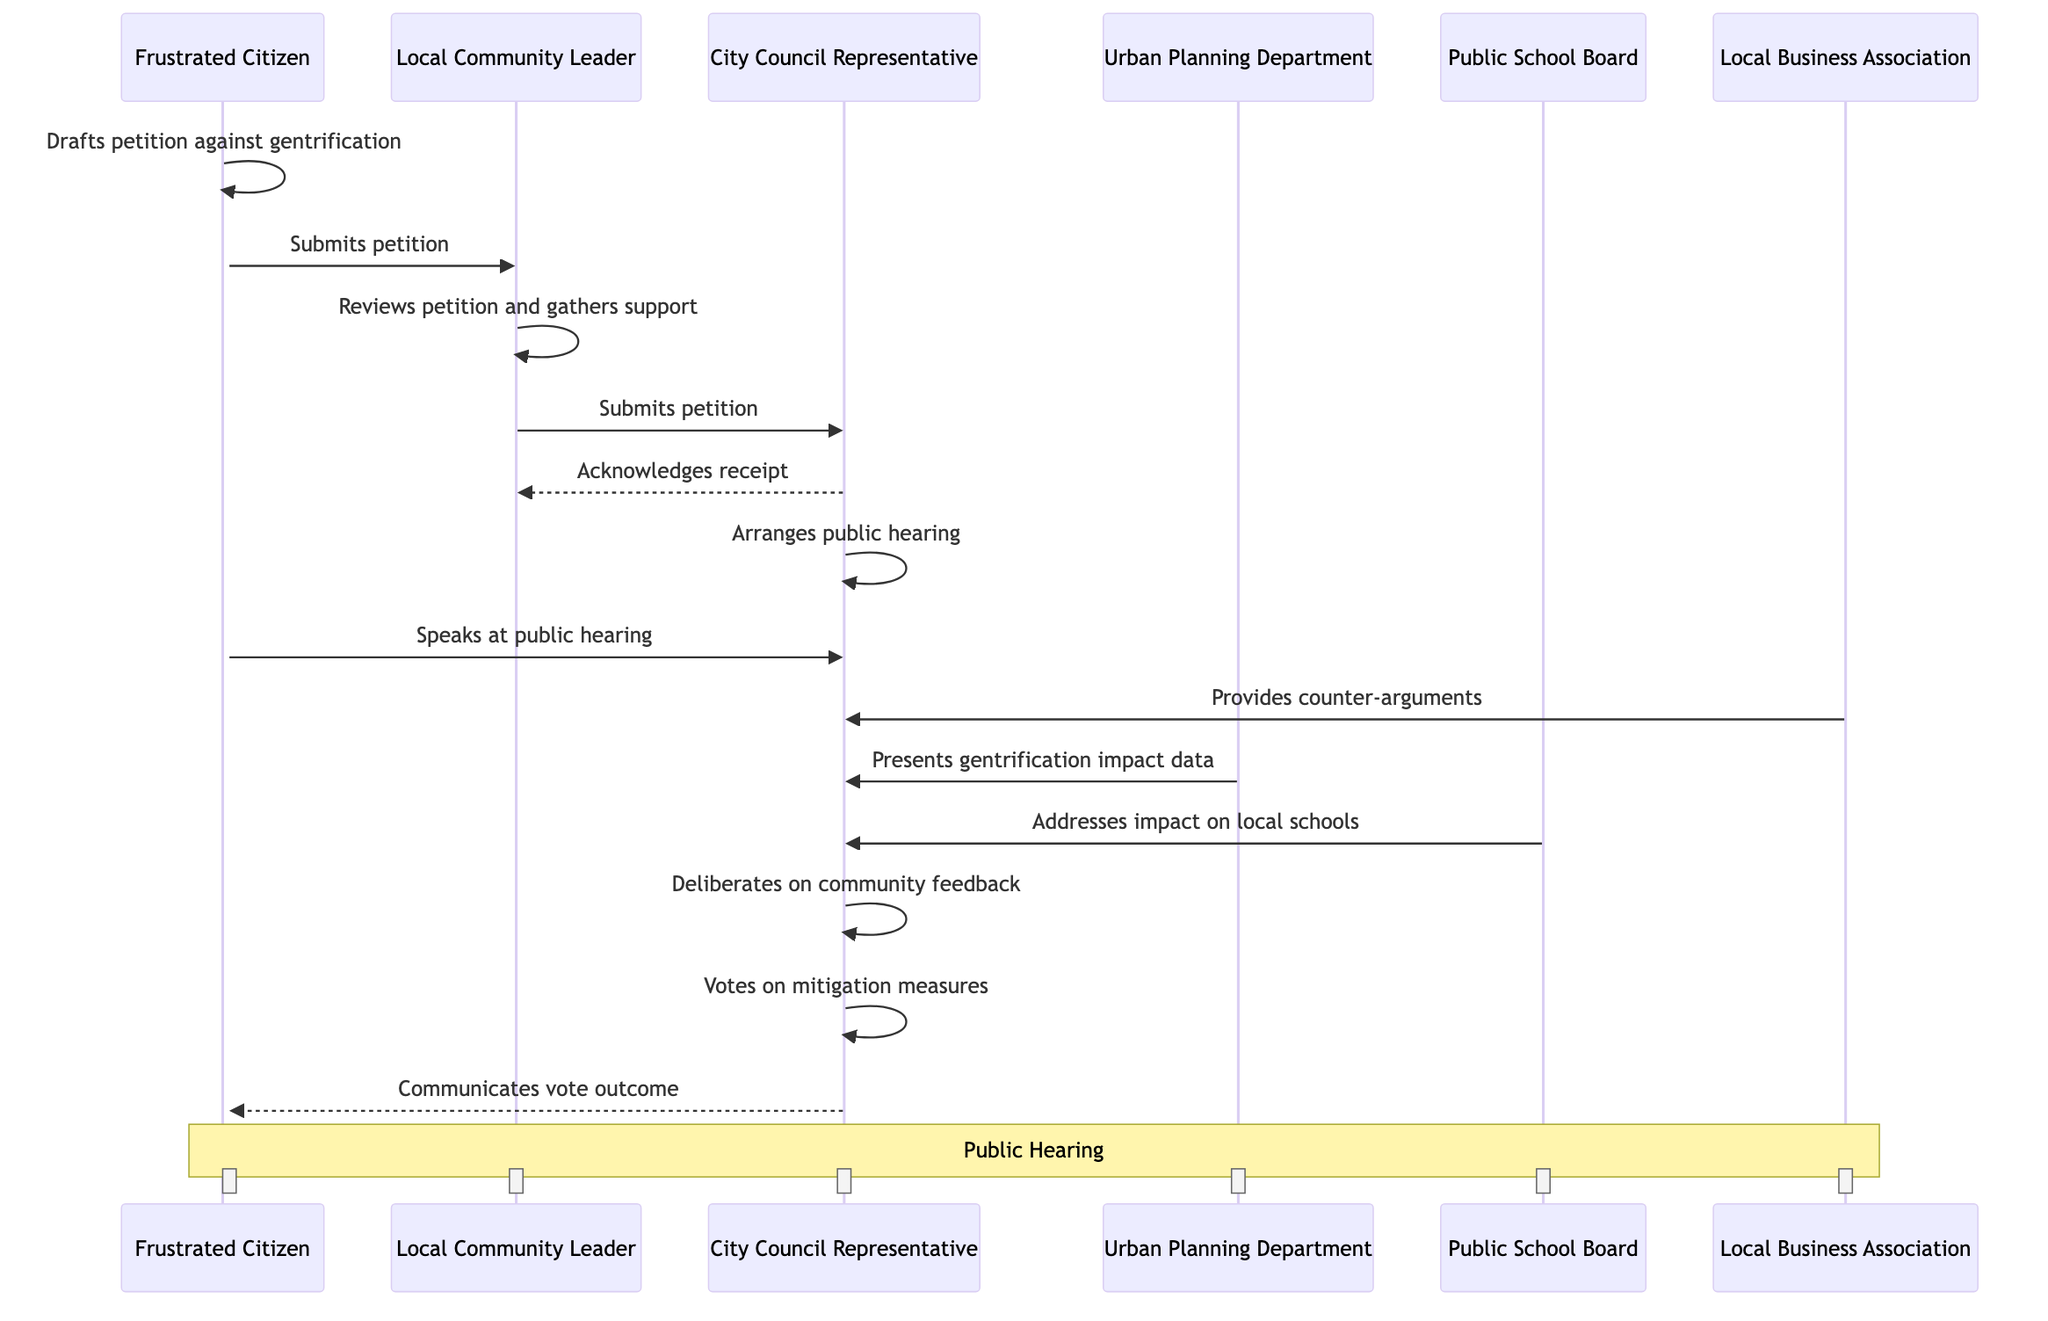What is the first action taken by the Frustrated Citizen? The diagram indicates that the first action taken by the Frustrated Citizen is to draft a petition against gentrification. This is the starting point of the sequence, clearly marked as their initial action.
Answer: Drafts petition against gentrification How many actors are involved in the petition process? By counting the participant nodes in the diagram, we can see that there are six distinct actors involved: Frustrated Citizen, Local Community Leader, City Council Representative, Urban Planning Department, Public School Board, and Local Business Association.
Answer: Six Who reviews the petition after it is submitted? After the Frustrated Citizen submits the petition, the Local Community Leader reviews it and gathers community support. This is indicated directly after the submission in the sequence.
Answer: Local Community Leader What happens after the City Council Representative acknowledges receipt of the petition? Once the City Council Representative acknowledges receipt of the petition, the next action in the sequence is for them to arrange a public hearing. This follows logically in the flow of actions in the diagram.
Answer: Arranges a public hearing Which actor presents data on gentrification impact? According to the diagram, the Urban Planning Department presents data on gentrification impact during the public hearing. This action follows the public hearing and is aimed at providing context for the council's deliberation.
Answer: Urban Planning Department What is the final action taken by the City Council Representative? The diagram indicates that the final action taken by the City Council Representative is to communicate the vote outcome to the Frustrated Citizen. This conclusion of the process is the last action recorded in the sequence.
Answer: Communicates vote outcome How many actions are indicated for the Local Business Association? The Local Business Association is indicated to have only one action in the diagram, which is to provide counter-arguments at the public hearing. This is clearly specified in the sequence and reflects their role during the hearing.
Answer: One What role does the Public School Board play in the public hearing? The Public School Board addresses the impact of gentrification on local schools, as specified in the sequence. This indicates their involvement and interest in the implications for education in the community.
Answer: Addresses impact on local schools Which actor is involved just before the City Council Representative deliberates on community feedback? Just before the City Council Representative deliberates on community feedback, they hear from the Public School Board regarding the impact on local schools. This sequence shows how different actors contribute to the discussion leading up to the deliberation.
Answer: Public School Board 